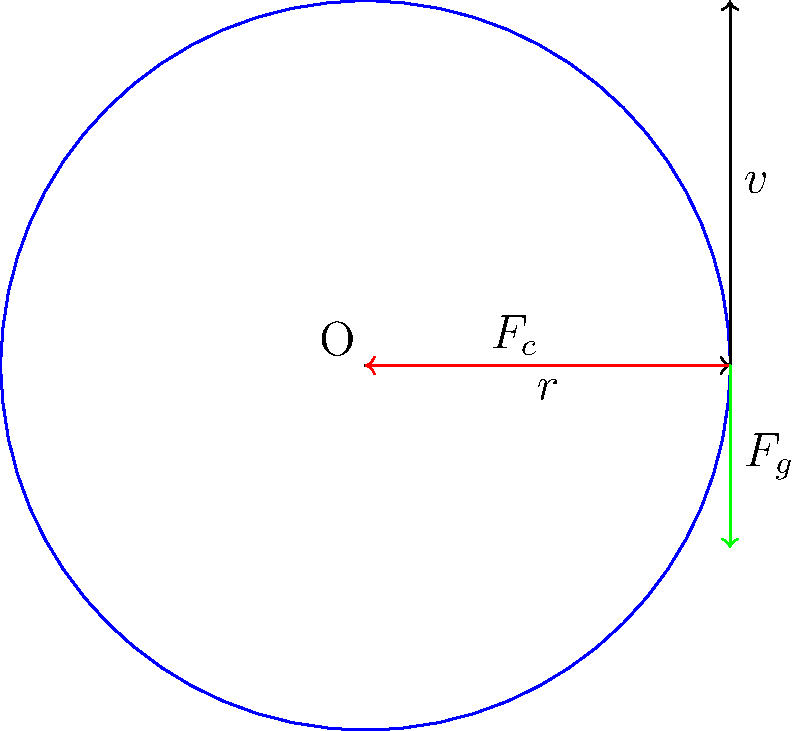A satellite orbits Earth in a circular path at a constant speed. The diagram shows the forces acting on the satellite at a particular point in its orbit. Explain how the gravitational force ($F_g$) provides the necessary centripetal force ($F_c$) for this circular motion. What would be the consequence if the gravitational force suddenly decreased? To understand how gravitational force provides the centripetal force for a satellite's circular orbit, let's break it down step-by-step:

1. Circular motion requires a constant centripetal force directed towards the center of the circle. In this case, the center is Earth (point O in the diagram).

2. The centripetal force is given by the equation:

   $$F_c = \frac{mv^2}{r}$$

   where $m$ is the mass of the satellite, $v$ is its velocity, and $r$ is the radius of the orbit.

3. For a satellite orbiting Earth, the only significant force acting on it is the gravitational force ($F_g$), which is always directed towards the center of Earth.

4. The gravitational force is given by Newton's law of universal gravitation:

   $$F_g = G\frac{Mm}{r^2}$$

   where $G$ is the gravitational constant, $M$ is the mass of Earth, and $m$ is the mass of the satellite.

5. For stable circular orbit, the gravitational force must equal the required centripetal force:

   $$F_g = F_c$$

   $$G\frac{Mm}{r^2} = \frac{mv^2}{r}$$

6. This equality allows the satellite to maintain a circular orbit at a constant speed.

If the gravitational force suddenly decreased:

7. The centripetal force would become insufficient to maintain the circular path.

8. The satellite would start moving in a spiral path away from Earth, as the outward inertial effect would no longer be fully counteracted by the reduced gravitational pull.

9. Eventually, if the decrease were significant enough, the satellite could escape Earth's orbit entirely, following a parabolic or hyperbolic trajectory.
Answer: Gravitational force provides the centripetal force for circular orbit. If decreased, the satellite would spiral outward, potentially escaping orbit. 